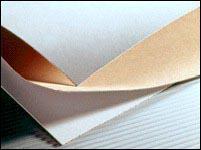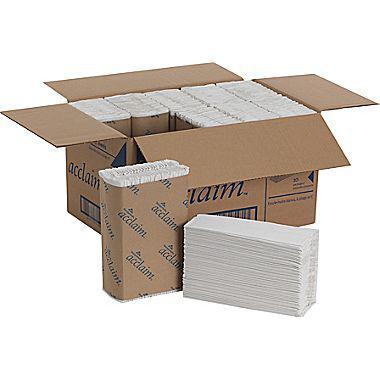The first image is the image on the left, the second image is the image on the right. Evaluate the accuracy of this statement regarding the images: "At least one of the paper products is available by the roll.". Is it true? Answer yes or no. No. The first image is the image on the left, the second image is the image on the right. Assess this claim about the two images: "No paper rolls are shown, but a stack of folded towels in a brown wrapper and a cardboard box are shown.". Correct or not? Answer yes or no. Yes. 